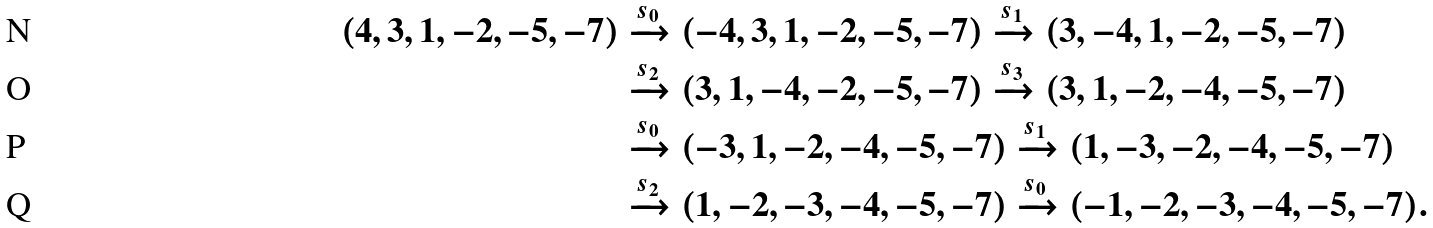<formula> <loc_0><loc_0><loc_500><loc_500>( 4 , 3 , 1 , - 2 , - 5 , - 7 ) & \xrightarrow { s _ { 0 } } ( - 4 , 3 , 1 , - 2 , - 5 , - 7 ) \xrightarrow { s _ { 1 } } ( 3 , - 4 , 1 , - 2 , - 5 , - 7 ) \\ & \xrightarrow { s _ { 2 } } ( 3 , 1 , - 4 , - 2 , - 5 , - 7 ) \xrightarrow { s _ { 3 } } ( 3 , 1 , - 2 , - 4 , - 5 , - 7 ) \\ & \xrightarrow { s _ { 0 } } ( - 3 , 1 , - 2 , - 4 , - 5 , - 7 ) \xrightarrow { s _ { 1 } } ( 1 , - 3 , - 2 , - 4 , - 5 , - 7 ) \\ & \xrightarrow { s _ { 2 } } ( 1 , - 2 , - 3 , - 4 , - 5 , - 7 ) \xrightarrow { s _ { 0 } } ( - 1 , - 2 , - 3 , - 4 , - 5 , - 7 ) .</formula> 